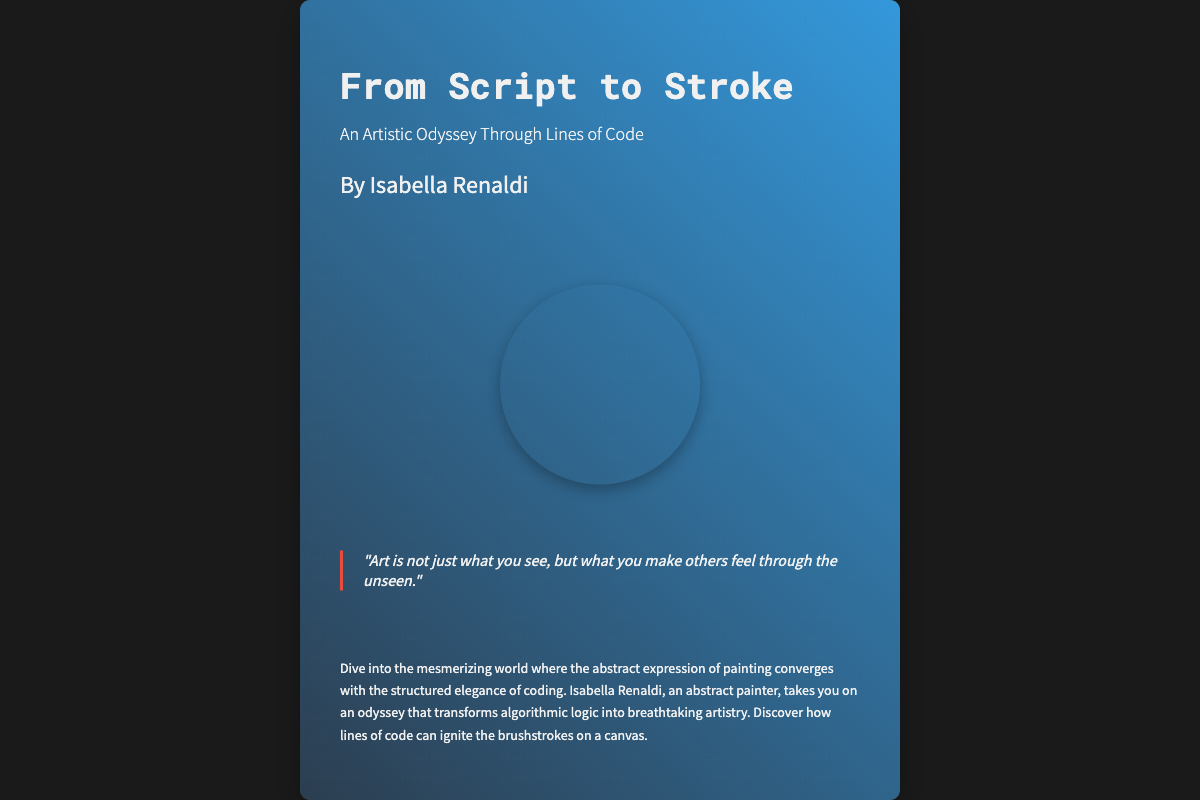What is the title of the book? The title of the book is prominently displayed in large font on the cover.
Answer: From Script to Stroke Who is the author of the book? The author's name is mentioned below the subtitle on the cover.
Answer: Isabella Renaldi What is the subtitle of the book? The subtitle is located beneath the title on the cover.
Answer: An Artistic Odyssey Through Lines of Code What is the main theme of the book? The description provides insight into the book's focus, specifically merging art and coding.
Answer: Merging art and coding What is the color scheme of the book cover? The background gradient and overall aesthetic depict the color choices made for the cover.
Answer: Dark blue and shades of grey What does the quote on the cover convey? The quote reflects the deeper essence of art, as highlighted on the cover.
Answer: Emotional impact of art What artistic elements are used on the cover? Observing the visual design elements shows the inclusion of abstract patterns.
Answer: Abstract patterns What is the size of the book cover? The dimensions can be deduced from the overall layout designed in the document.
Answer: 600 by 800 pixels How is the text presented on the book cover? The font style of the text indicates a modern aesthetic as described in the styles used.
Answer: Modern monospace fonts 